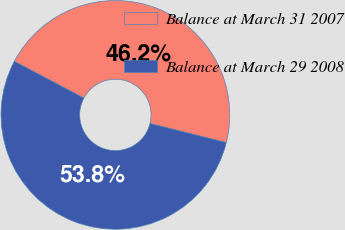Convert chart. <chart><loc_0><loc_0><loc_500><loc_500><pie_chart><fcel>Balance at March 31 2007<fcel>Balance at March 29 2008<nl><fcel>46.16%<fcel>53.84%<nl></chart> 